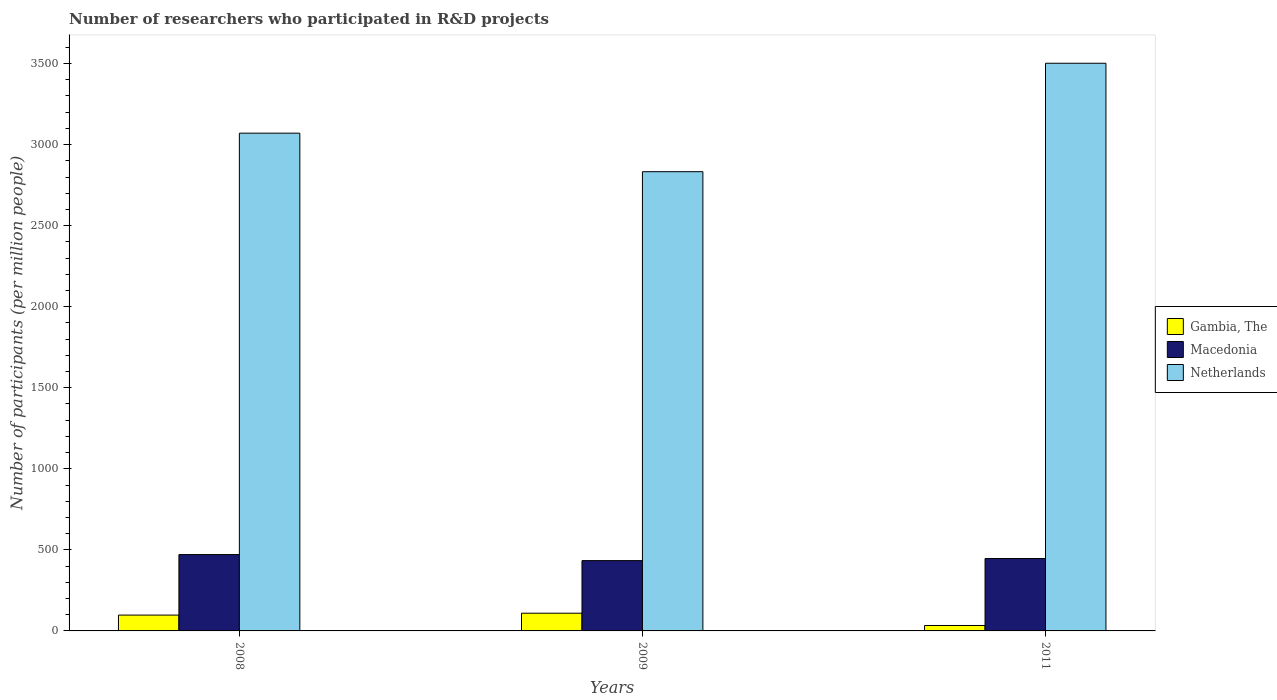How many different coloured bars are there?
Your answer should be very brief. 3. How many groups of bars are there?
Offer a terse response. 3. How many bars are there on the 2nd tick from the left?
Make the answer very short. 3. How many bars are there on the 3rd tick from the right?
Ensure brevity in your answer.  3. In how many cases, is the number of bars for a given year not equal to the number of legend labels?
Offer a very short reply. 0. What is the number of researchers who participated in R&D projects in Gambia, The in 2008?
Your answer should be compact. 97.68. Across all years, what is the maximum number of researchers who participated in R&D projects in Gambia, The?
Provide a succinct answer. 109.22. Across all years, what is the minimum number of researchers who participated in R&D projects in Macedonia?
Make the answer very short. 433.72. What is the total number of researchers who participated in R&D projects in Macedonia in the graph?
Ensure brevity in your answer.  1351.35. What is the difference between the number of researchers who participated in R&D projects in Netherlands in 2008 and that in 2011?
Your answer should be very brief. -431.29. What is the difference between the number of researchers who participated in R&D projects in Macedonia in 2008 and the number of researchers who participated in R&D projects in Gambia, The in 2011?
Make the answer very short. 437.48. What is the average number of researchers who participated in R&D projects in Gambia, The per year?
Make the answer very short. 80.14. In the year 2011, what is the difference between the number of researchers who participated in R&D projects in Macedonia and number of researchers who participated in R&D projects in Netherlands?
Offer a very short reply. -3055.32. What is the ratio of the number of researchers who participated in R&D projects in Gambia, The in 2008 to that in 2009?
Your response must be concise. 0.89. Is the number of researchers who participated in R&D projects in Gambia, The in 2008 less than that in 2009?
Provide a short and direct response. Yes. Is the difference between the number of researchers who participated in R&D projects in Macedonia in 2009 and 2011 greater than the difference between the number of researchers who participated in R&D projects in Netherlands in 2009 and 2011?
Your answer should be compact. Yes. What is the difference between the highest and the second highest number of researchers who participated in R&D projects in Macedonia?
Your response must be concise. 24.34. What is the difference between the highest and the lowest number of researchers who participated in R&D projects in Macedonia?
Give a very brief answer. 37.26. In how many years, is the number of researchers who participated in R&D projects in Netherlands greater than the average number of researchers who participated in R&D projects in Netherlands taken over all years?
Your answer should be compact. 1. Is the sum of the number of researchers who participated in R&D projects in Netherlands in 2009 and 2011 greater than the maximum number of researchers who participated in R&D projects in Macedonia across all years?
Give a very brief answer. Yes. What does the 1st bar from the left in 2011 represents?
Make the answer very short. Gambia, The. What does the 3rd bar from the right in 2009 represents?
Provide a succinct answer. Gambia, The. Is it the case that in every year, the sum of the number of researchers who participated in R&D projects in Netherlands and number of researchers who participated in R&D projects in Gambia, The is greater than the number of researchers who participated in R&D projects in Macedonia?
Provide a short and direct response. Yes. How many bars are there?
Give a very brief answer. 9. Are all the bars in the graph horizontal?
Your answer should be compact. No. How many years are there in the graph?
Offer a terse response. 3. Where does the legend appear in the graph?
Give a very brief answer. Center right. How many legend labels are there?
Your answer should be compact. 3. What is the title of the graph?
Your answer should be very brief. Number of researchers who participated in R&D projects. Does "Netherlands" appear as one of the legend labels in the graph?
Your answer should be very brief. Yes. What is the label or title of the X-axis?
Your answer should be compact. Years. What is the label or title of the Y-axis?
Your answer should be compact. Number of participants (per million people). What is the Number of participants (per million people) in Gambia, The in 2008?
Offer a terse response. 97.68. What is the Number of participants (per million people) in Macedonia in 2008?
Keep it short and to the point. 470.99. What is the Number of participants (per million people) in Netherlands in 2008?
Make the answer very short. 3070.67. What is the Number of participants (per million people) of Gambia, The in 2009?
Make the answer very short. 109.22. What is the Number of participants (per million people) of Macedonia in 2009?
Provide a succinct answer. 433.72. What is the Number of participants (per million people) of Netherlands in 2009?
Offer a terse response. 2833.03. What is the Number of participants (per million people) in Gambia, The in 2011?
Your answer should be very brief. 33.5. What is the Number of participants (per million people) of Macedonia in 2011?
Keep it short and to the point. 446.65. What is the Number of participants (per million people) of Netherlands in 2011?
Offer a very short reply. 3501.96. Across all years, what is the maximum Number of participants (per million people) of Gambia, The?
Offer a very short reply. 109.22. Across all years, what is the maximum Number of participants (per million people) in Macedonia?
Offer a very short reply. 470.99. Across all years, what is the maximum Number of participants (per million people) of Netherlands?
Make the answer very short. 3501.96. Across all years, what is the minimum Number of participants (per million people) of Gambia, The?
Provide a succinct answer. 33.5. Across all years, what is the minimum Number of participants (per million people) in Macedonia?
Offer a very short reply. 433.72. Across all years, what is the minimum Number of participants (per million people) of Netherlands?
Your answer should be compact. 2833.03. What is the total Number of participants (per million people) of Gambia, The in the graph?
Keep it short and to the point. 240.41. What is the total Number of participants (per million people) of Macedonia in the graph?
Ensure brevity in your answer.  1351.35. What is the total Number of participants (per million people) in Netherlands in the graph?
Make the answer very short. 9405.66. What is the difference between the Number of participants (per million people) of Gambia, The in 2008 and that in 2009?
Your answer should be very brief. -11.54. What is the difference between the Number of participants (per million people) in Macedonia in 2008 and that in 2009?
Give a very brief answer. 37.26. What is the difference between the Number of participants (per million people) in Netherlands in 2008 and that in 2009?
Offer a very short reply. 237.63. What is the difference between the Number of participants (per million people) in Gambia, The in 2008 and that in 2011?
Keep it short and to the point. 64.18. What is the difference between the Number of participants (per million people) of Macedonia in 2008 and that in 2011?
Ensure brevity in your answer.  24.34. What is the difference between the Number of participants (per million people) of Netherlands in 2008 and that in 2011?
Provide a succinct answer. -431.29. What is the difference between the Number of participants (per million people) in Gambia, The in 2009 and that in 2011?
Offer a very short reply. 75.72. What is the difference between the Number of participants (per million people) in Macedonia in 2009 and that in 2011?
Keep it short and to the point. -12.92. What is the difference between the Number of participants (per million people) of Netherlands in 2009 and that in 2011?
Make the answer very short. -668.93. What is the difference between the Number of participants (per million people) of Gambia, The in 2008 and the Number of participants (per million people) of Macedonia in 2009?
Your answer should be very brief. -336.04. What is the difference between the Number of participants (per million people) in Gambia, The in 2008 and the Number of participants (per million people) in Netherlands in 2009?
Provide a short and direct response. -2735.35. What is the difference between the Number of participants (per million people) of Macedonia in 2008 and the Number of participants (per million people) of Netherlands in 2009?
Give a very brief answer. -2362.05. What is the difference between the Number of participants (per million people) of Gambia, The in 2008 and the Number of participants (per million people) of Macedonia in 2011?
Your answer should be very brief. -348.96. What is the difference between the Number of participants (per million people) in Gambia, The in 2008 and the Number of participants (per million people) in Netherlands in 2011?
Provide a succinct answer. -3404.28. What is the difference between the Number of participants (per million people) of Macedonia in 2008 and the Number of participants (per million people) of Netherlands in 2011?
Your response must be concise. -3030.98. What is the difference between the Number of participants (per million people) of Gambia, The in 2009 and the Number of participants (per million people) of Macedonia in 2011?
Keep it short and to the point. -337.43. What is the difference between the Number of participants (per million people) in Gambia, The in 2009 and the Number of participants (per million people) in Netherlands in 2011?
Keep it short and to the point. -3392.74. What is the difference between the Number of participants (per million people) in Macedonia in 2009 and the Number of participants (per million people) in Netherlands in 2011?
Offer a very short reply. -3068.24. What is the average Number of participants (per million people) in Gambia, The per year?
Your answer should be very brief. 80.14. What is the average Number of participants (per million people) of Macedonia per year?
Your answer should be very brief. 450.45. What is the average Number of participants (per million people) of Netherlands per year?
Your answer should be compact. 3135.22. In the year 2008, what is the difference between the Number of participants (per million people) in Gambia, The and Number of participants (per million people) in Macedonia?
Provide a short and direct response. -373.3. In the year 2008, what is the difference between the Number of participants (per million people) of Gambia, The and Number of participants (per million people) of Netherlands?
Ensure brevity in your answer.  -2972.98. In the year 2008, what is the difference between the Number of participants (per million people) of Macedonia and Number of participants (per million people) of Netherlands?
Provide a succinct answer. -2599.68. In the year 2009, what is the difference between the Number of participants (per million people) in Gambia, The and Number of participants (per million people) in Macedonia?
Provide a succinct answer. -324.5. In the year 2009, what is the difference between the Number of participants (per million people) in Gambia, The and Number of participants (per million people) in Netherlands?
Provide a short and direct response. -2723.81. In the year 2009, what is the difference between the Number of participants (per million people) of Macedonia and Number of participants (per million people) of Netherlands?
Offer a terse response. -2399.31. In the year 2011, what is the difference between the Number of participants (per million people) in Gambia, The and Number of participants (per million people) in Macedonia?
Offer a very short reply. -413.14. In the year 2011, what is the difference between the Number of participants (per million people) of Gambia, The and Number of participants (per million people) of Netherlands?
Keep it short and to the point. -3468.46. In the year 2011, what is the difference between the Number of participants (per million people) of Macedonia and Number of participants (per million people) of Netherlands?
Your answer should be compact. -3055.32. What is the ratio of the Number of participants (per million people) of Gambia, The in 2008 to that in 2009?
Offer a very short reply. 0.89. What is the ratio of the Number of participants (per million people) of Macedonia in 2008 to that in 2009?
Your answer should be very brief. 1.09. What is the ratio of the Number of participants (per million people) of Netherlands in 2008 to that in 2009?
Your answer should be compact. 1.08. What is the ratio of the Number of participants (per million people) in Gambia, The in 2008 to that in 2011?
Your answer should be compact. 2.92. What is the ratio of the Number of participants (per million people) of Macedonia in 2008 to that in 2011?
Ensure brevity in your answer.  1.05. What is the ratio of the Number of participants (per million people) of Netherlands in 2008 to that in 2011?
Your answer should be compact. 0.88. What is the ratio of the Number of participants (per million people) in Gambia, The in 2009 to that in 2011?
Keep it short and to the point. 3.26. What is the ratio of the Number of participants (per million people) in Macedonia in 2009 to that in 2011?
Provide a short and direct response. 0.97. What is the ratio of the Number of participants (per million people) in Netherlands in 2009 to that in 2011?
Provide a succinct answer. 0.81. What is the difference between the highest and the second highest Number of participants (per million people) in Gambia, The?
Provide a succinct answer. 11.54. What is the difference between the highest and the second highest Number of participants (per million people) in Macedonia?
Give a very brief answer. 24.34. What is the difference between the highest and the second highest Number of participants (per million people) of Netherlands?
Your answer should be compact. 431.29. What is the difference between the highest and the lowest Number of participants (per million people) of Gambia, The?
Ensure brevity in your answer.  75.72. What is the difference between the highest and the lowest Number of participants (per million people) of Macedonia?
Ensure brevity in your answer.  37.26. What is the difference between the highest and the lowest Number of participants (per million people) in Netherlands?
Provide a succinct answer. 668.93. 